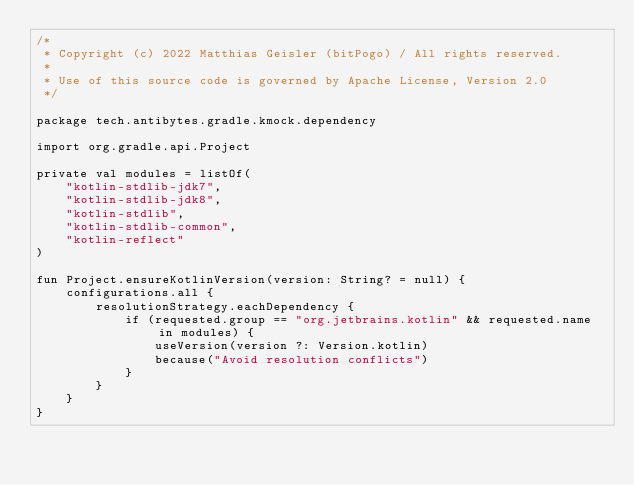Convert code to text. <code><loc_0><loc_0><loc_500><loc_500><_Kotlin_>/*
 * Copyright (c) 2022 Matthias Geisler (bitPogo) / All rights reserved.
 *
 * Use of this source code is governed by Apache License, Version 2.0
 */

package tech.antibytes.gradle.kmock.dependency

import org.gradle.api.Project

private val modules = listOf(
    "kotlin-stdlib-jdk7",
    "kotlin-stdlib-jdk8",
    "kotlin-stdlib",
    "kotlin-stdlib-common",
    "kotlin-reflect"
)

fun Project.ensureKotlinVersion(version: String? = null) {
    configurations.all {
        resolutionStrategy.eachDependency {
            if (requested.group == "org.jetbrains.kotlin" && requested.name in modules) {
                useVersion(version ?: Version.kotlin)
                because("Avoid resolution conflicts")
            }
        }
    }
}
</code> 